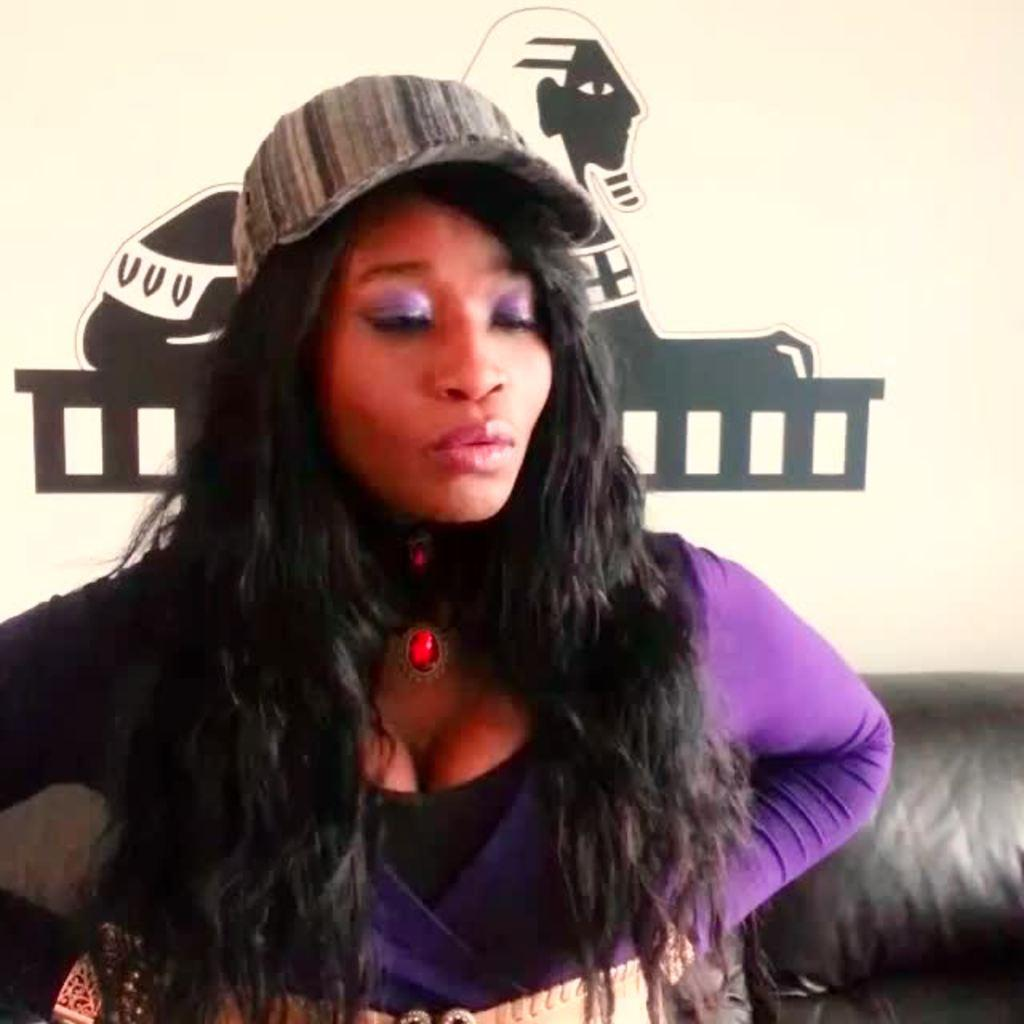What is the main subject in the foreground of the picture? There is a woman in the foreground of the picture. What is the woman wearing in the picture? The woman is wearing a violet color dress and a cap. What can be seen in the background of the picture? There is a couch and a wall in the background of the picture. Can you see any squirrels or clams interacting with the woman in the picture? No, there are no squirrels or clams present in the image. Is the woman holding any honey in the picture? There is no honey visible in the image. 